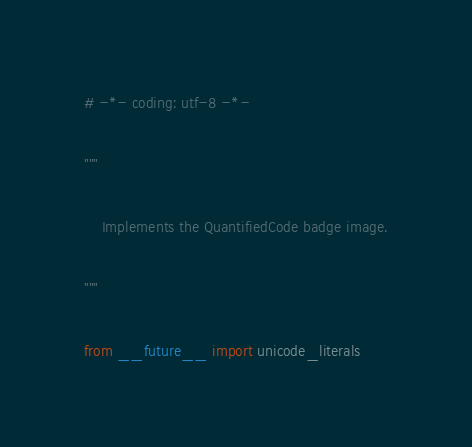Convert code to text. <code><loc_0><loc_0><loc_500><loc_500><_Python_># -*- coding: utf-8 -*-

"""

    Implements the QuantifiedCode badge image.

"""

from __future__ import unicode_literals</code> 